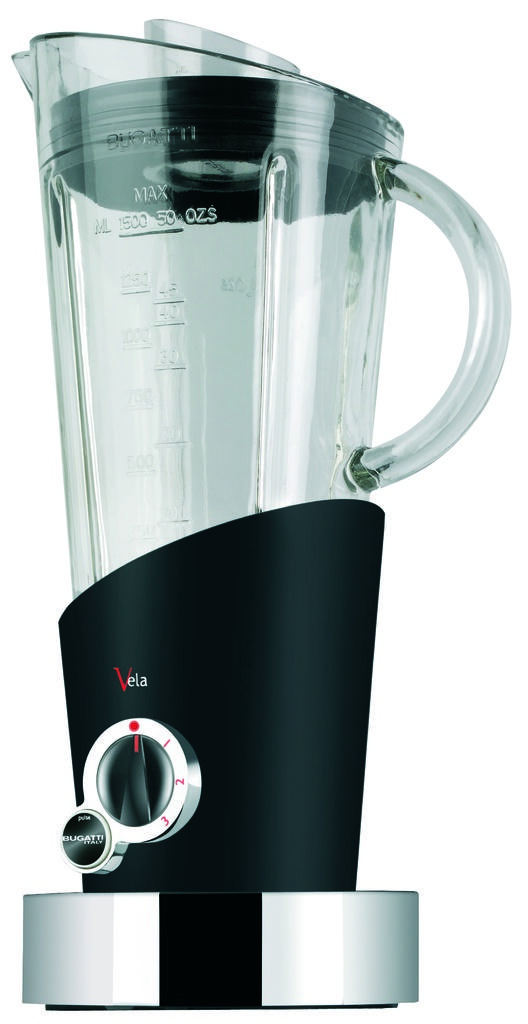What is the brand of this appliance?
Provide a short and direct response. Vela. 